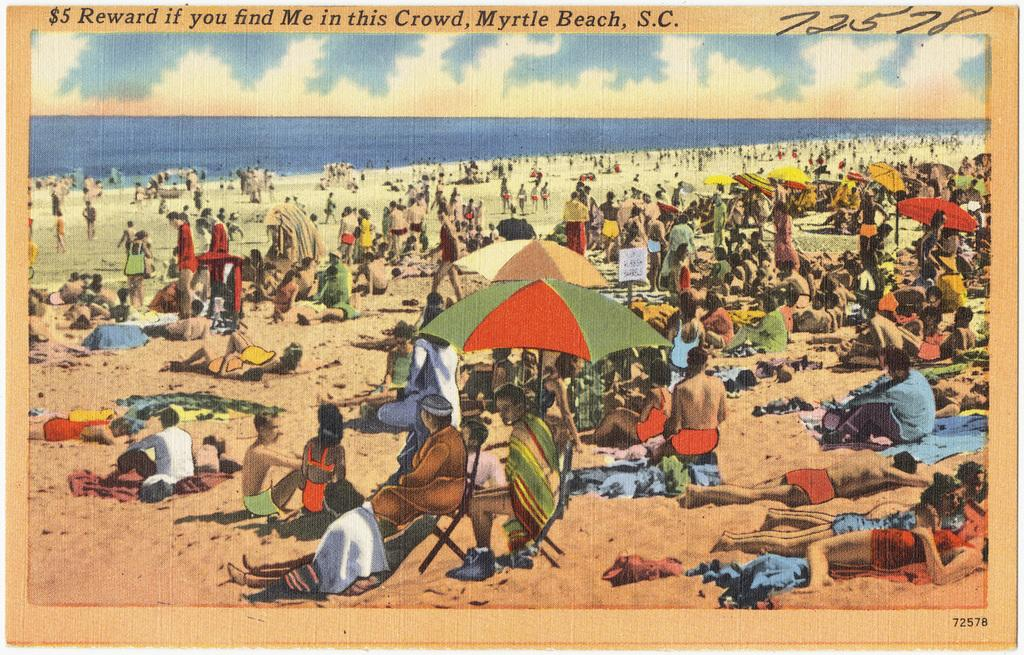<image>
Offer a succinct explanation of the picture presented. old photo of myrtle beach that offers five dollar reward if you find a certain person 